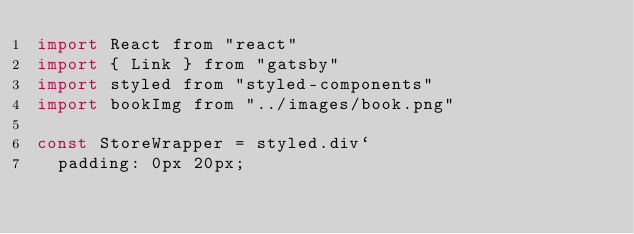Convert code to text. <code><loc_0><loc_0><loc_500><loc_500><_JavaScript_>import React from "react"
import { Link } from "gatsby"
import styled from "styled-components"
import bookImg from "../images/book.png"

const StoreWrapper = styled.div`
  padding: 0px 20px;</code> 